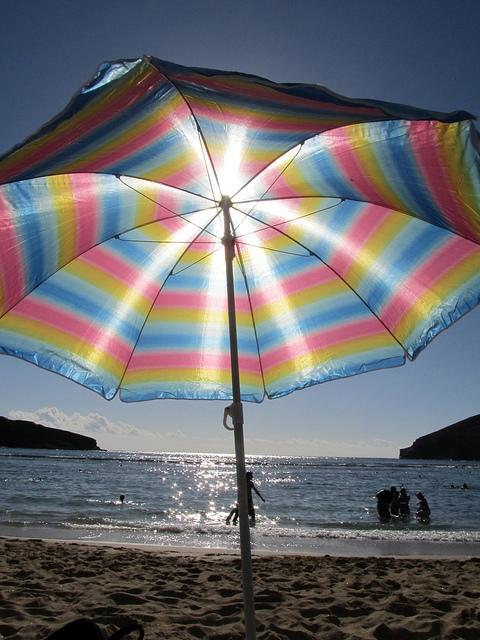What is planted in the sand?

Choices:
A) net
B) tent
C) flag
D) umbrella umbrella 